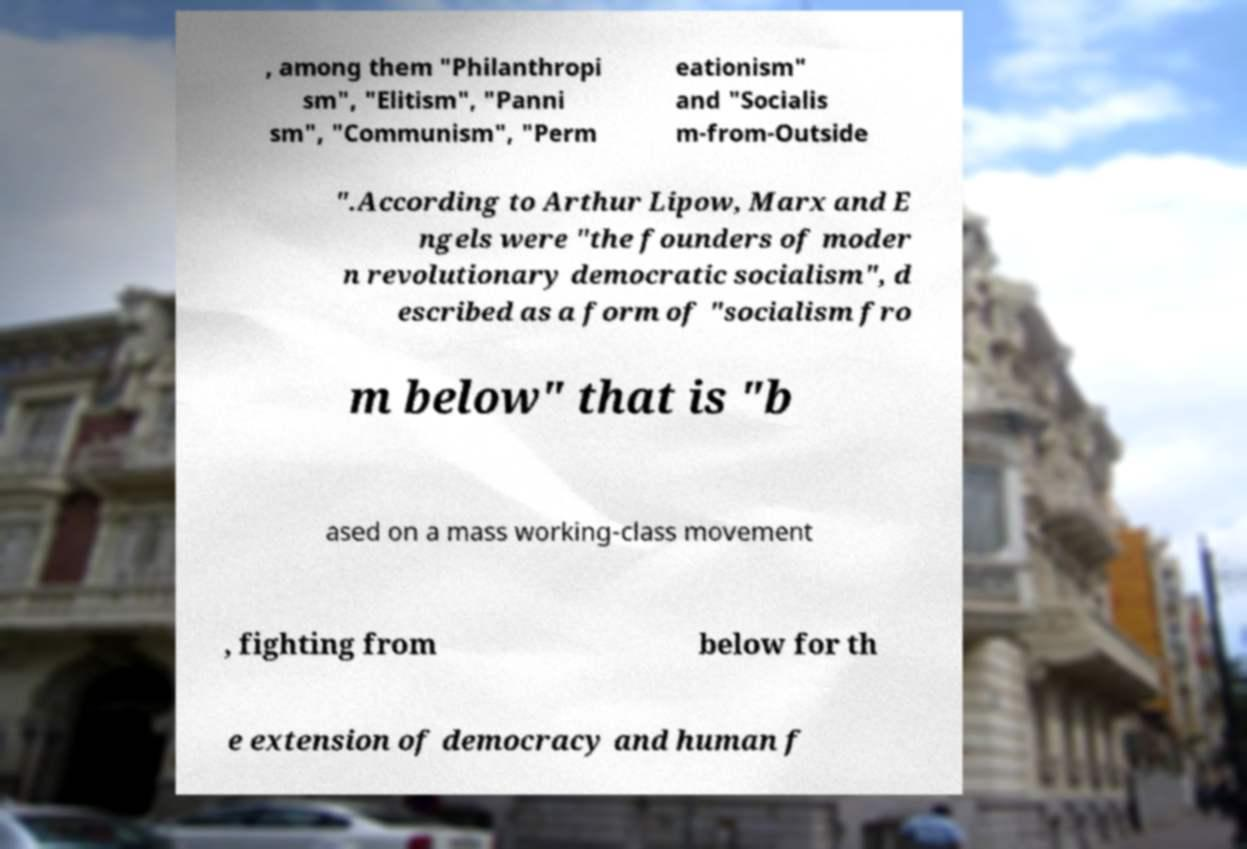For documentation purposes, I need the text within this image transcribed. Could you provide that? , among them "Philanthropi sm", "Elitism", "Panni sm", "Communism", "Perm eationism" and "Socialis m-from-Outside ".According to Arthur Lipow, Marx and E ngels were "the founders of moder n revolutionary democratic socialism", d escribed as a form of "socialism fro m below" that is "b ased on a mass working-class movement , fighting from below for th e extension of democracy and human f 